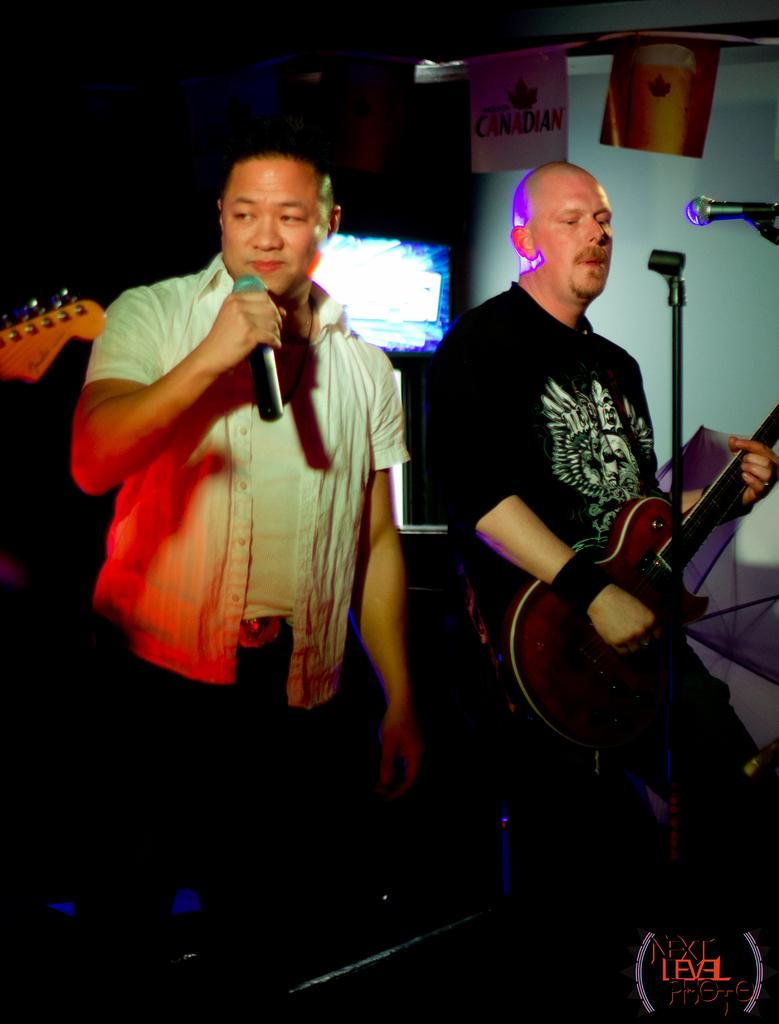What is the person in the white shirt holding in the image? The person in the white shirt is holding a mic in their hands. What is the person in the black t-shirt holding in the image? The person in the black t-shirt is holding a guitar in their hands. What is the person in the black t-shirt doing with the guitar? The person in the black t-shirt is playing the guitar. What is the position of the person in the white shirt in the image? The person in the white shirt is standing. What type of wheel is visible in the image? There is no wheel present in the image. Is the person in the white shirt a writer in the image? There is no information about the person's profession in the image, so we cannot determine if they are a writer. 